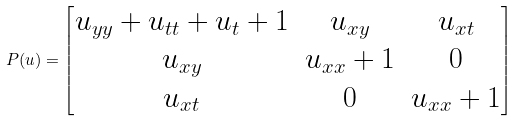<formula> <loc_0><loc_0><loc_500><loc_500>P ( u ) = \begin{bmatrix} u _ { y y } + u _ { t t } + u _ { t } + 1 & u _ { x y } & u _ { x t } \\ u _ { x y } & u _ { x x } + 1 & 0 \\ u _ { x t } & 0 & u _ { x x } + 1 \end{bmatrix}</formula> 